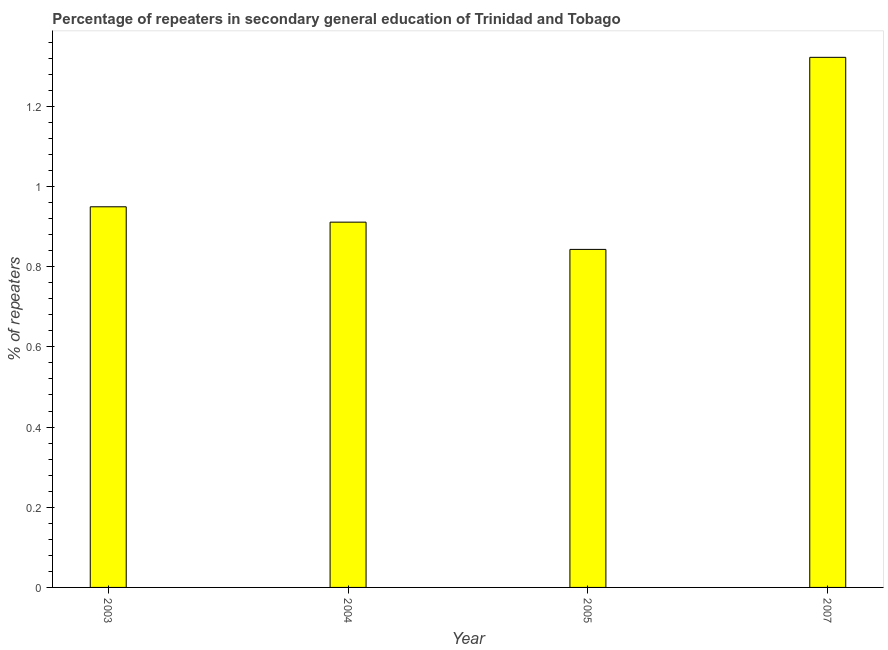Does the graph contain any zero values?
Make the answer very short. No. Does the graph contain grids?
Your response must be concise. No. What is the title of the graph?
Your response must be concise. Percentage of repeaters in secondary general education of Trinidad and Tobago. What is the label or title of the X-axis?
Make the answer very short. Year. What is the label or title of the Y-axis?
Give a very brief answer. % of repeaters. What is the percentage of repeaters in 2005?
Your response must be concise. 0.84. Across all years, what is the maximum percentage of repeaters?
Offer a terse response. 1.32. Across all years, what is the minimum percentage of repeaters?
Your response must be concise. 0.84. In which year was the percentage of repeaters maximum?
Provide a short and direct response. 2007. What is the sum of the percentage of repeaters?
Give a very brief answer. 4.03. What is the difference between the percentage of repeaters in 2005 and 2007?
Offer a very short reply. -0.48. What is the median percentage of repeaters?
Keep it short and to the point. 0.93. In how many years, is the percentage of repeaters greater than 0.88 %?
Your answer should be compact. 3. Do a majority of the years between 2003 and 2007 (inclusive) have percentage of repeaters greater than 0.12 %?
Ensure brevity in your answer.  Yes. What is the ratio of the percentage of repeaters in 2003 to that in 2004?
Provide a short and direct response. 1.04. What is the difference between the highest and the second highest percentage of repeaters?
Keep it short and to the point. 0.37. Is the sum of the percentage of repeaters in 2004 and 2007 greater than the maximum percentage of repeaters across all years?
Provide a succinct answer. Yes. What is the difference between the highest and the lowest percentage of repeaters?
Keep it short and to the point. 0.48. How many bars are there?
Your response must be concise. 4. Are all the bars in the graph horizontal?
Provide a succinct answer. No. What is the % of repeaters in 2003?
Give a very brief answer. 0.95. What is the % of repeaters in 2004?
Give a very brief answer. 0.91. What is the % of repeaters of 2005?
Keep it short and to the point. 0.84. What is the % of repeaters in 2007?
Your answer should be very brief. 1.32. What is the difference between the % of repeaters in 2003 and 2004?
Your answer should be compact. 0.04. What is the difference between the % of repeaters in 2003 and 2005?
Make the answer very short. 0.11. What is the difference between the % of repeaters in 2003 and 2007?
Keep it short and to the point. -0.37. What is the difference between the % of repeaters in 2004 and 2005?
Your response must be concise. 0.07. What is the difference between the % of repeaters in 2004 and 2007?
Keep it short and to the point. -0.41. What is the difference between the % of repeaters in 2005 and 2007?
Your answer should be very brief. -0.48. What is the ratio of the % of repeaters in 2003 to that in 2004?
Make the answer very short. 1.04. What is the ratio of the % of repeaters in 2003 to that in 2005?
Your response must be concise. 1.13. What is the ratio of the % of repeaters in 2003 to that in 2007?
Your response must be concise. 0.72. What is the ratio of the % of repeaters in 2004 to that in 2005?
Offer a very short reply. 1.08. What is the ratio of the % of repeaters in 2004 to that in 2007?
Give a very brief answer. 0.69. What is the ratio of the % of repeaters in 2005 to that in 2007?
Ensure brevity in your answer.  0.64. 